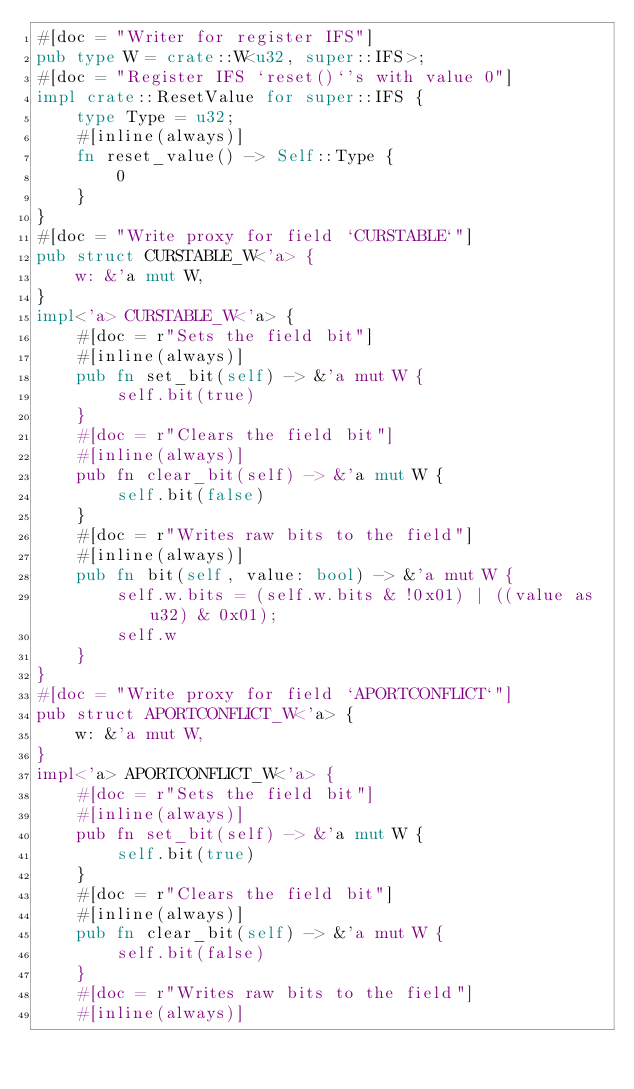Convert code to text. <code><loc_0><loc_0><loc_500><loc_500><_Rust_>#[doc = "Writer for register IFS"]
pub type W = crate::W<u32, super::IFS>;
#[doc = "Register IFS `reset()`'s with value 0"]
impl crate::ResetValue for super::IFS {
    type Type = u32;
    #[inline(always)]
    fn reset_value() -> Self::Type {
        0
    }
}
#[doc = "Write proxy for field `CURSTABLE`"]
pub struct CURSTABLE_W<'a> {
    w: &'a mut W,
}
impl<'a> CURSTABLE_W<'a> {
    #[doc = r"Sets the field bit"]
    #[inline(always)]
    pub fn set_bit(self) -> &'a mut W {
        self.bit(true)
    }
    #[doc = r"Clears the field bit"]
    #[inline(always)]
    pub fn clear_bit(self) -> &'a mut W {
        self.bit(false)
    }
    #[doc = r"Writes raw bits to the field"]
    #[inline(always)]
    pub fn bit(self, value: bool) -> &'a mut W {
        self.w.bits = (self.w.bits & !0x01) | ((value as u32) & 0x01);
        self.w
    }
}
#[doc = "Write proxy for field `APORTCONFLICT`"]
pub struct APORTCONFLICT_W<'a> {
    w: &'a mut W,
}
impl<'a> APORTCONFLICT_W<'a> {
    #[doc = r"Sets the field bit"]
    #[inline(always)]
    pub fn set_bit(self) -> &'a mut W {
        self.bit(true)
    }
    #[doc = r"Clears the field bit"]
    #[inline(always)]
    pub fn clear_bit(self) -> &'a mut W {
        self.bit(false)
    }
    #[doc = r"Writes raw bits to the field"]
    #[inline(always)]</code> 